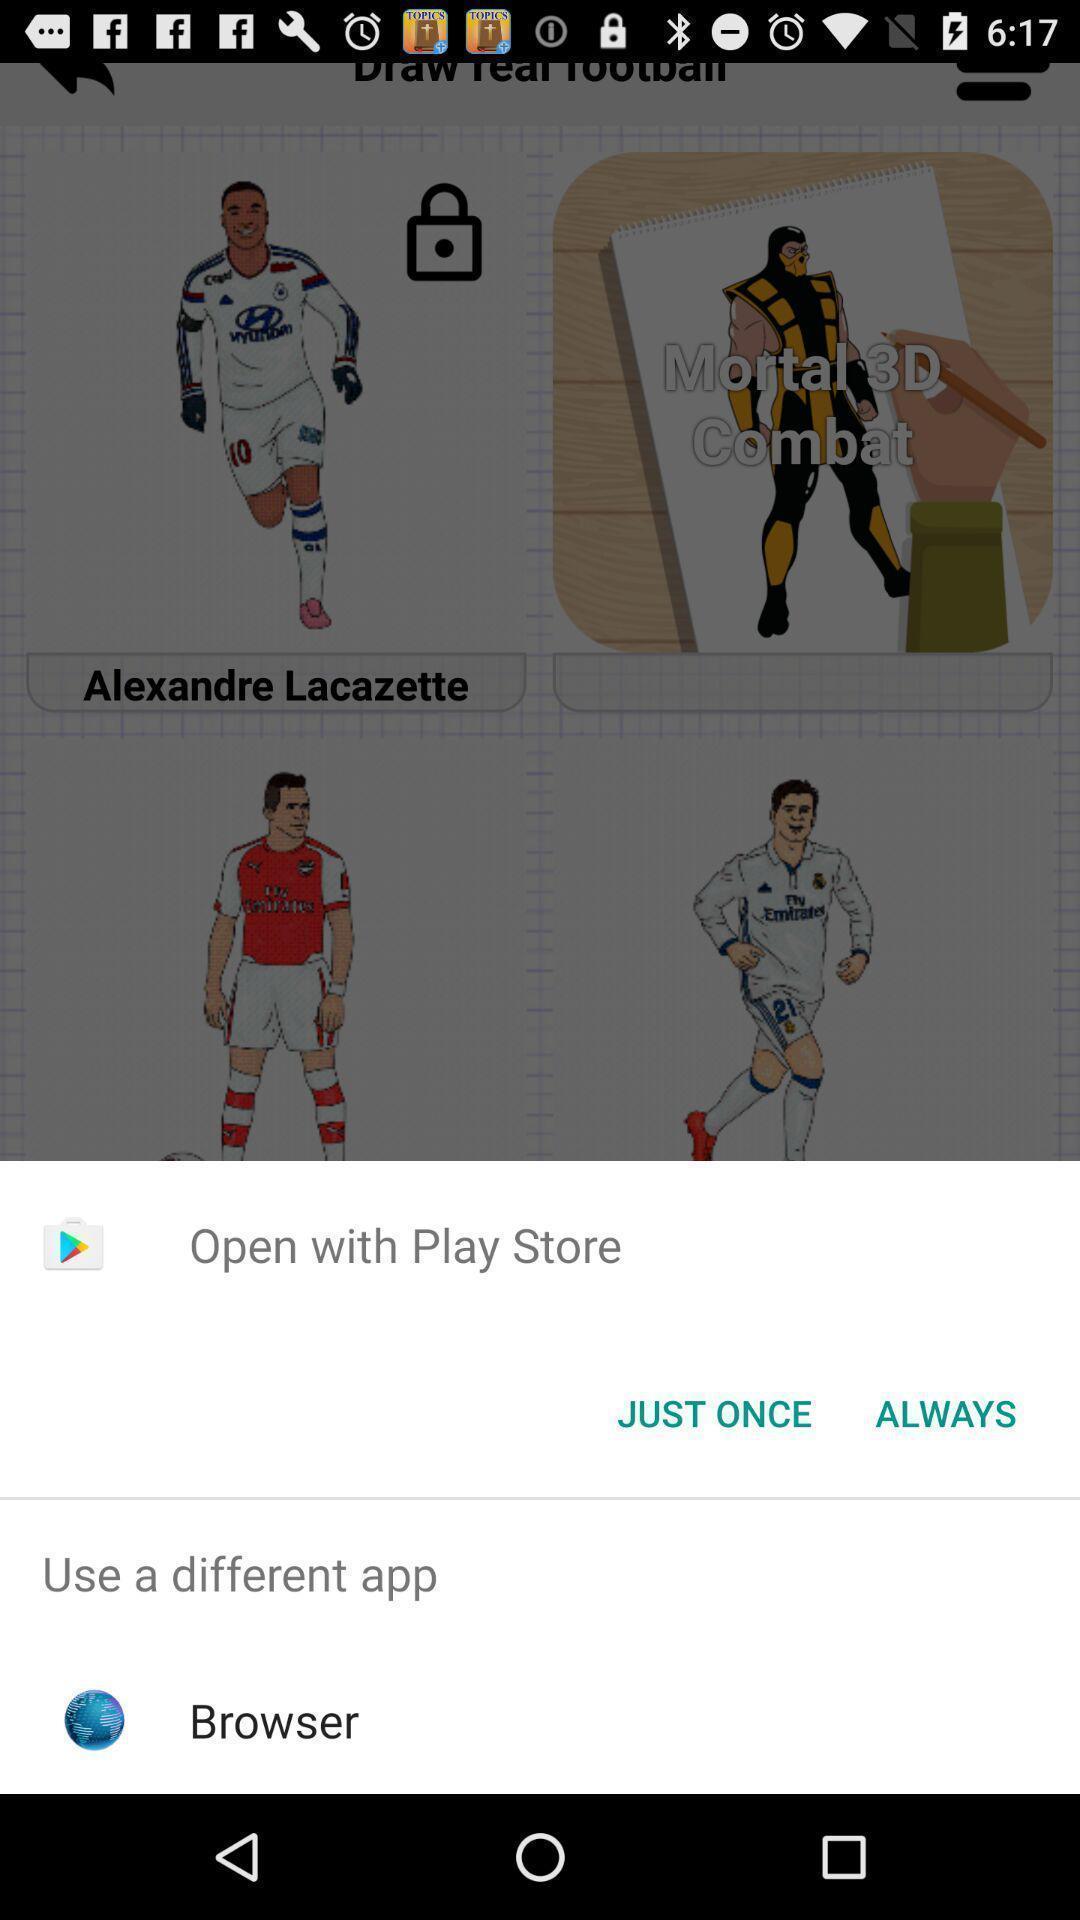Provide a textual representation of this image. Pop up message. 